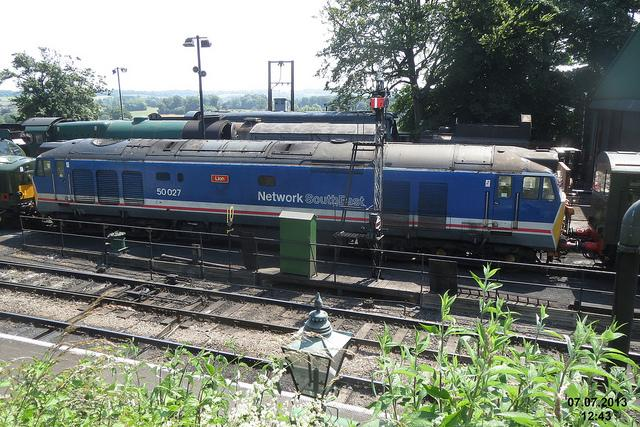What is the first number that appears on the train? Please explain your reasoning. five. The first number printed on the side of the train is a five. 